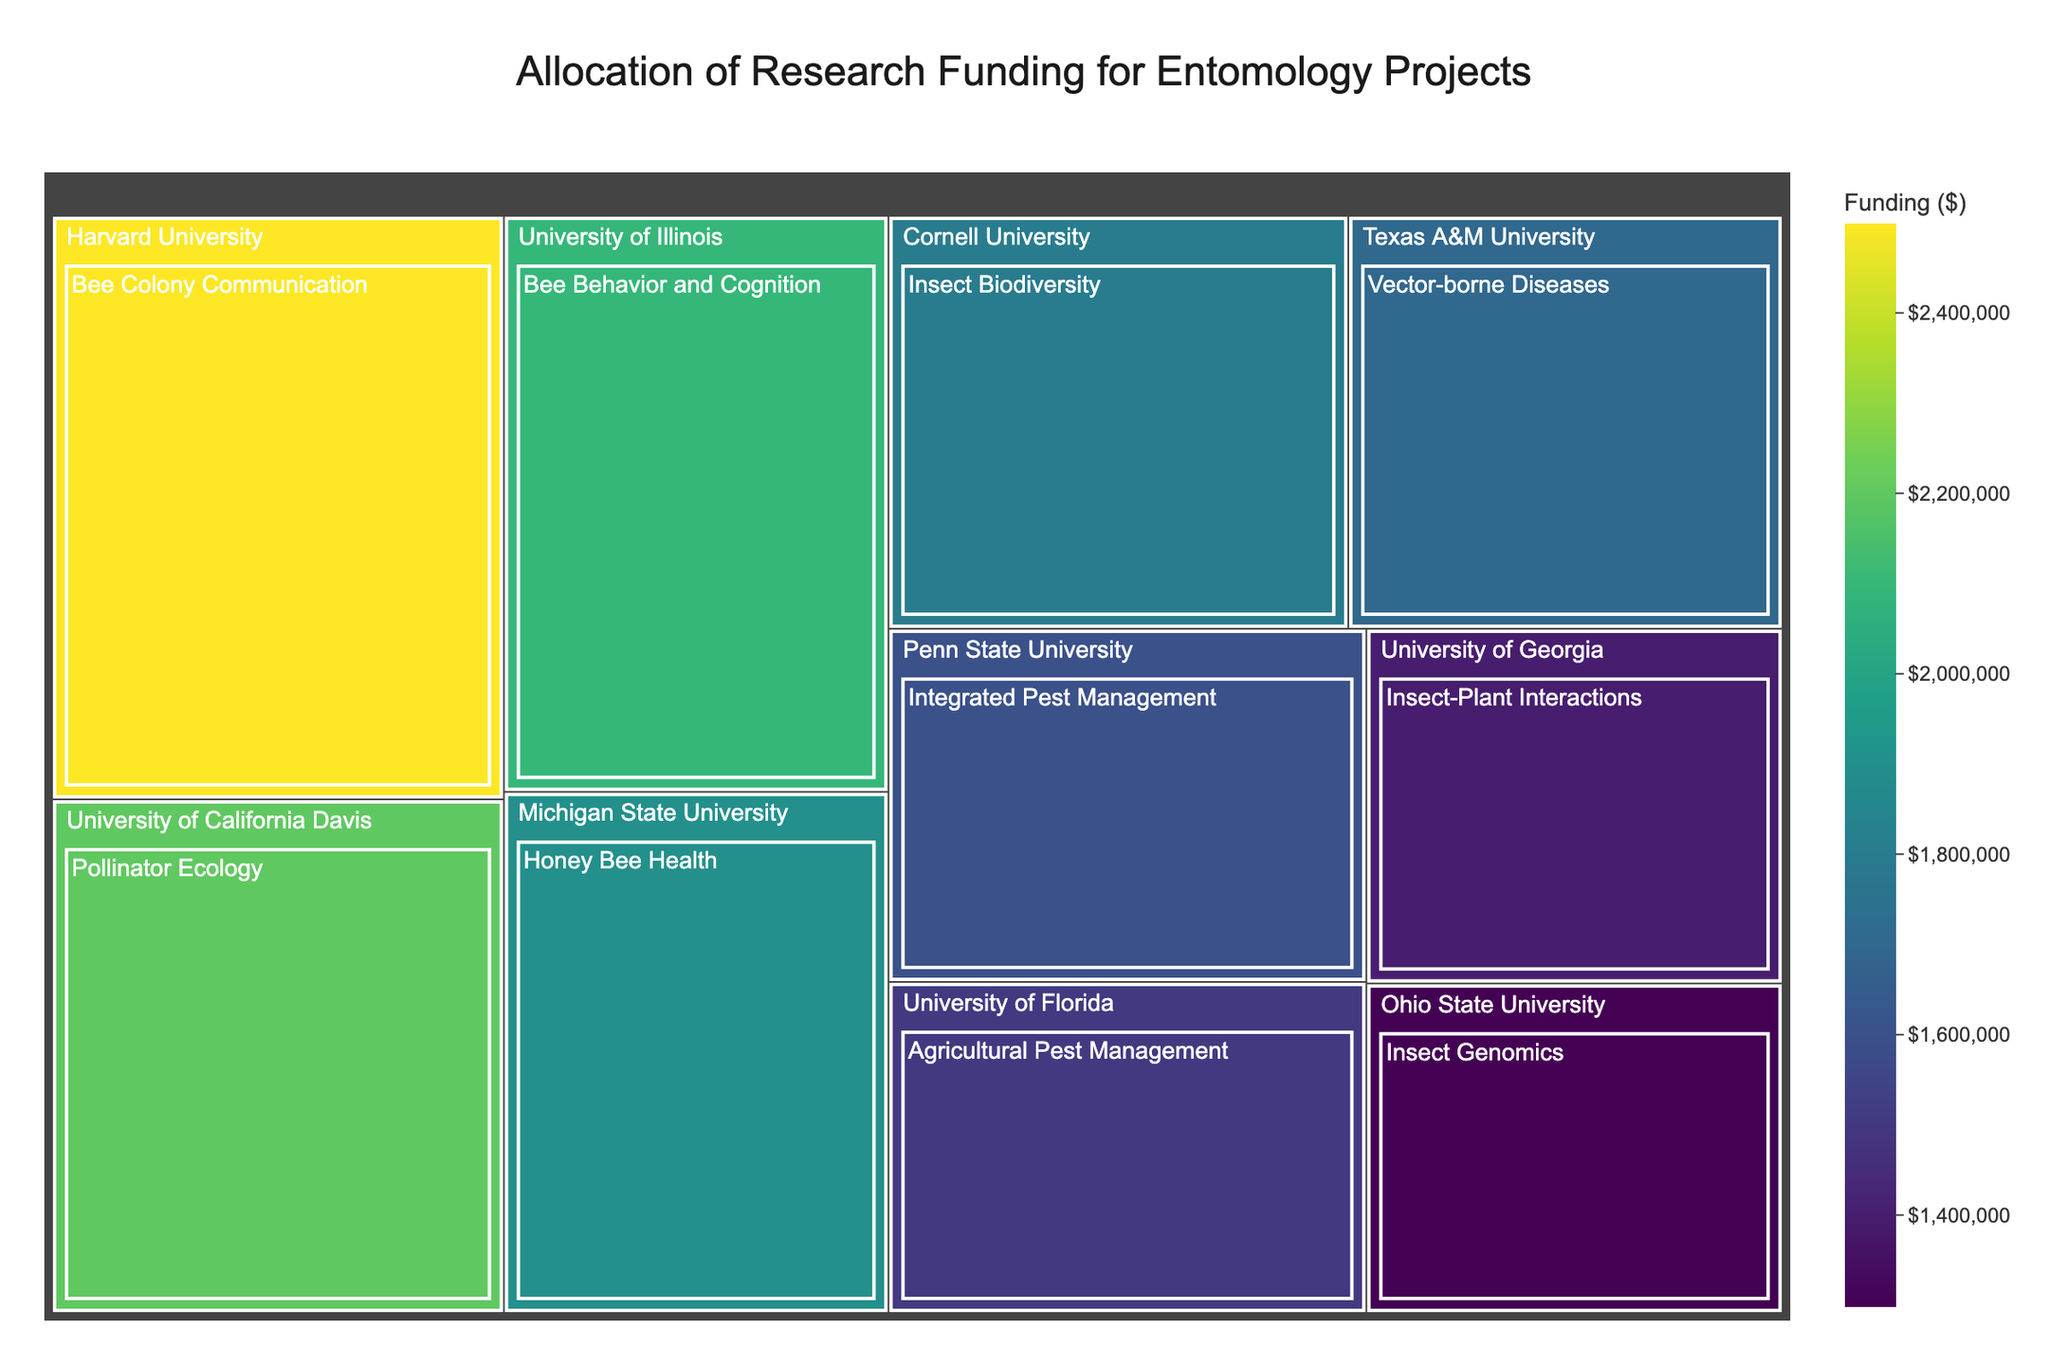How much funding did the Bee Colony Communication project at Harvard University receive? To find this, look for Harvard University in the Treemap. Within Harvard, locate the Bee Colony Communication project and read its associated funding.
Answer: $2,500,000 Which university received the highest funding for any single project? Scan through the Treemap squares to find the project with the largest funding value. The largest square will indicate the highest amount of funding.
Answer: Harvard University What is the total funding allocated to entomology projects across all universities? Sum the funding amounts for all projects listed in the Treemap. Let's add them up: 2,500,000 for Harvard, 1,800,000 for Cornell, 2,200,000 for UC Davis, 1,500,000 for Florida, 1,900,000 for Michigan State, 1,300,000 for Ohio State, 1,600,000 for Penn State, 2,100,000 for Illinois, 1,700,000 for Texas A&M, and 1,400,000 for Georgia. The total is 17,000,000.
Answer: $17,000,000 Which project received less funding: Insect Biodiversity at Cornell University or Pollinator Ecology at UC Davis? Locate the funding for Insect Biodiversity at Cornell University (1,800,000) and Pollinator Ecology at UC Davis (2,200,000) from the Treemap. Compare the two amounts to determine which is less.
Answer: Insect Biodiversity Among University of Florida and Michigan State University, which university received more funding for their respective projects and by how much? Identify the funding for University of Florida (1,500,000) and Michigan State University (1,900,000) from the Treemap. Then calculate the difference: 1,900,000 - 1,500,000.
Answer: Michigan State University, by $400,000 Which project at University of Illinois deals with bees, and how much funding did it receive? Locate University of Illinois on the Treemap and identify the project related to bees, which is "Bee Behavior and Cognition," and note its funding amount.
Answer: Bee Behavior and Cognition, $2,100,000 How many universities have projects with funding over $2,000,000? Scan through the Treemap and count the universities that have at least one project with funding over $2,000,000. These universities are Harvard University, UC Davis, and University of Illinois.
Answer: 3 Which university's project on Integrated Pest Management received funding, and how much was it? Locate the project named Integrated Pest Management on the Treemap and identify the associated university and its funding amount. The project is associated with Penn State University, and the funding is $1,600,000.
Answer: Penn State University, $1,600,000 What is the average funding for the ten projects listed in the Treemap? Sum all the funding amounts and then divide by the number of projects. The total funding is $17,000,000 and there are 10 projects. The average is calculated as follows: 17,000,000 / 10.
Answer: $1,700,000 